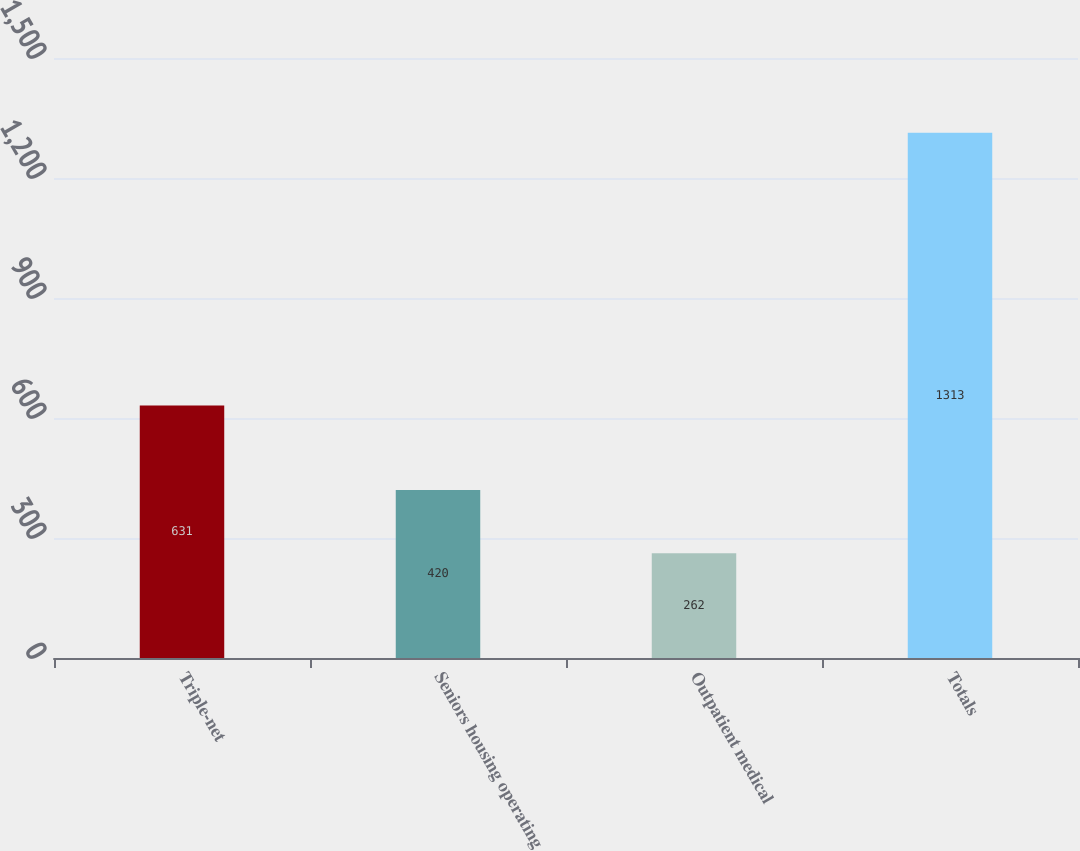Convert chart. <chart><loc_0><loc_0><loc_500><loc_500><bar_chart><fcel>Triple-net<fcel>Seniors housing operating<fcel>Outpatient medical<fcel>Totals<nl><fcel>631<fcel>420<fcel>262<fcel>1313<nl></chart> 